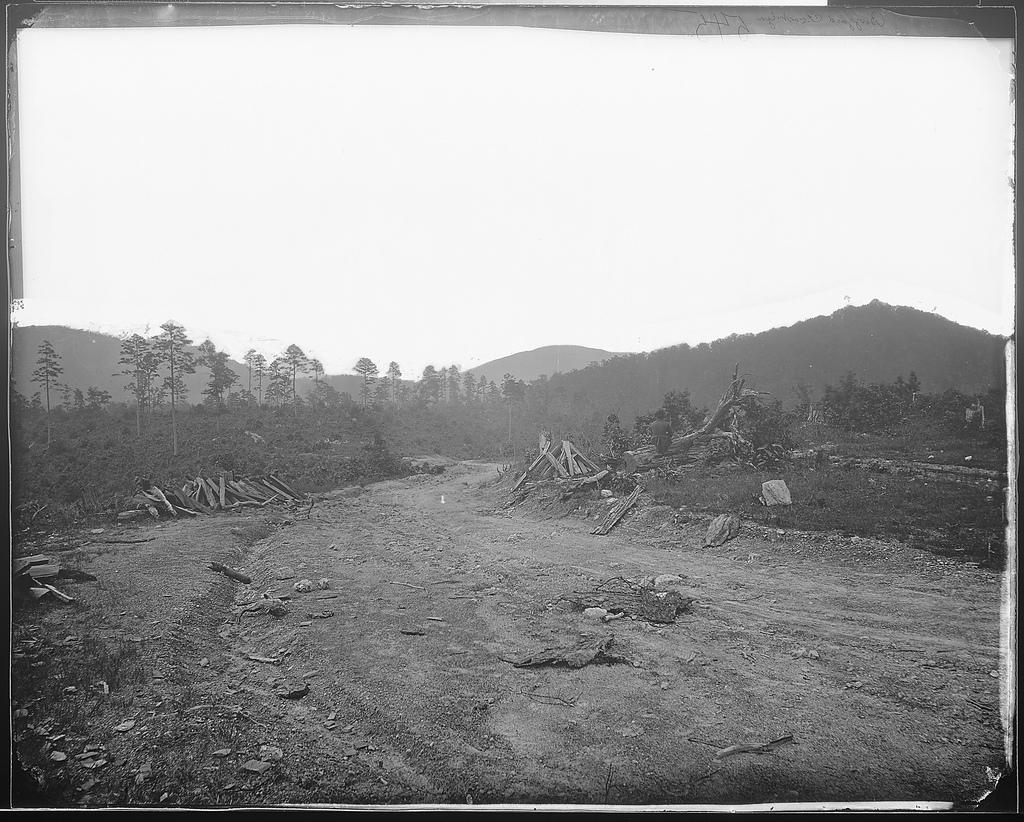What objects are on the ground in the image? There are wooden sticks on the ground in the image. What type of vegetation is present in the image? There are trees in the image. What geographical features can be seen in the background of the image? There are mountains in the background of the image. What part of the natural environment is visible in the image? The sky is visible in the background of the image. What type of wire is being used for the operation in the image? There is no wire or operation present in the image; it features wooden sticks, trees, mountains, and the sky. 